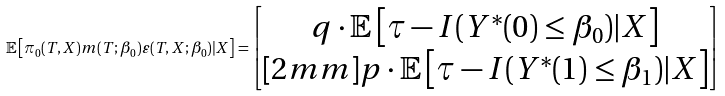<formula> <loc_0><loc_0><loc_500><loc_500>\mathbb { E } \left [ \pi _ { 0 } ( T , X ) m ( T ; \beta _ { 0 } ) \varepsilon ( T , X ; \beta _ { 0 } ) | X \right ] = \begin{bmatrix} q \cdot \mathbb { E } \left [ \tau - I ( Y ^ { * } ( 0 ) \leq \beta _ { 0 } ) | X \right ] \\ [ 2 m m ] p \cdot \mathbb { E } \left [ \tau - I ( Y ^ { * } ( 1 ) \leq \beta _ { 1 } ) | X \right ] \end{bmatrix}</formula> 